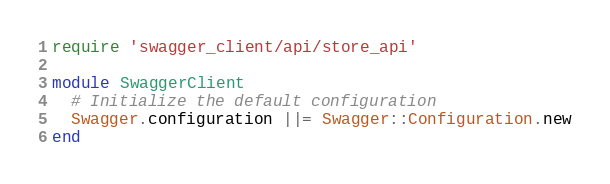Convert code to text. <code><loc_0><loc_0><loc_500><loc_500><_Ruby_>require 'swagger_client/api/store_api'

module SwaggerClient
  # Initialize the default configuration
  Swagger.configuration ||= Swagger::Configuration.new
end</code> 